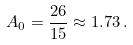Convert formula to latex. <formula><loc_0><loc_0><loc_500><loc_500>A _ { 0 } = \frac { 2 6 } { 1 5 } \approx 1 . 7 3 \, .</formula> 